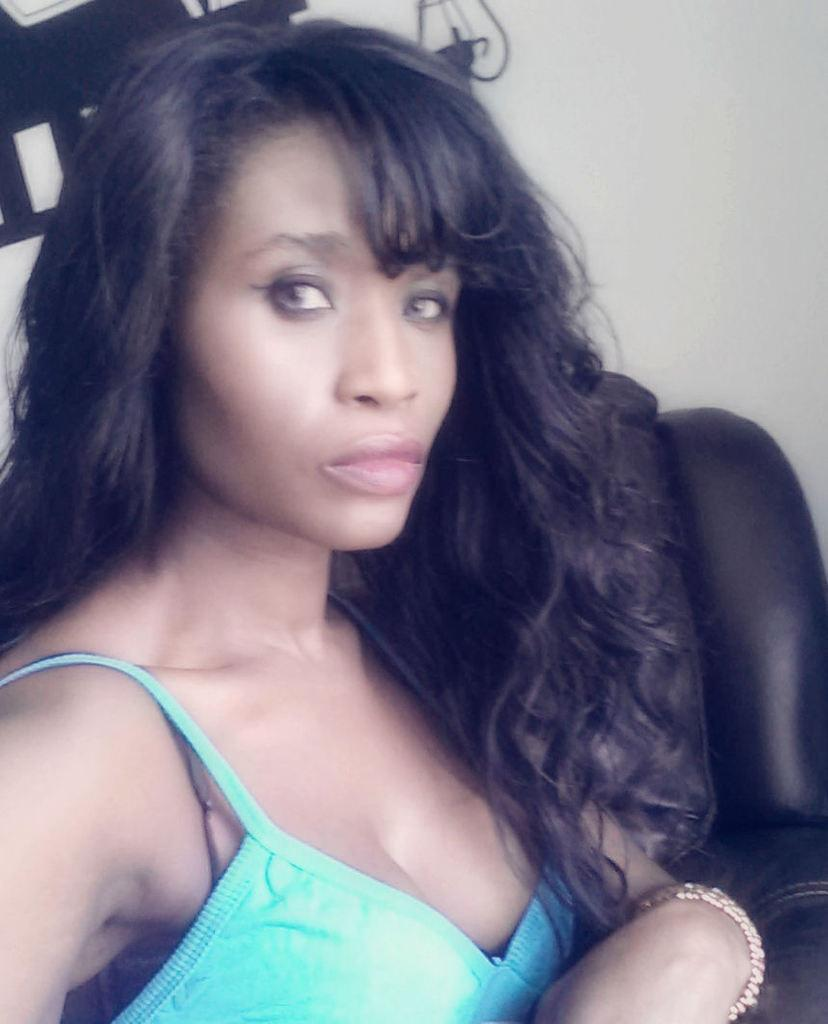Who is the main subject in the image? There is a woman in the image. What is the woman doing in the image? The woman is sitting on a couch. What can be seen in the background of the image? There is a wall in the background of the image. What is on the wall in the image? There is a painting on the wall. What type of engine can be seen in the painting on the wall? There is no engine visible in the image, as the painting on the wall is not described in the provided facts. 